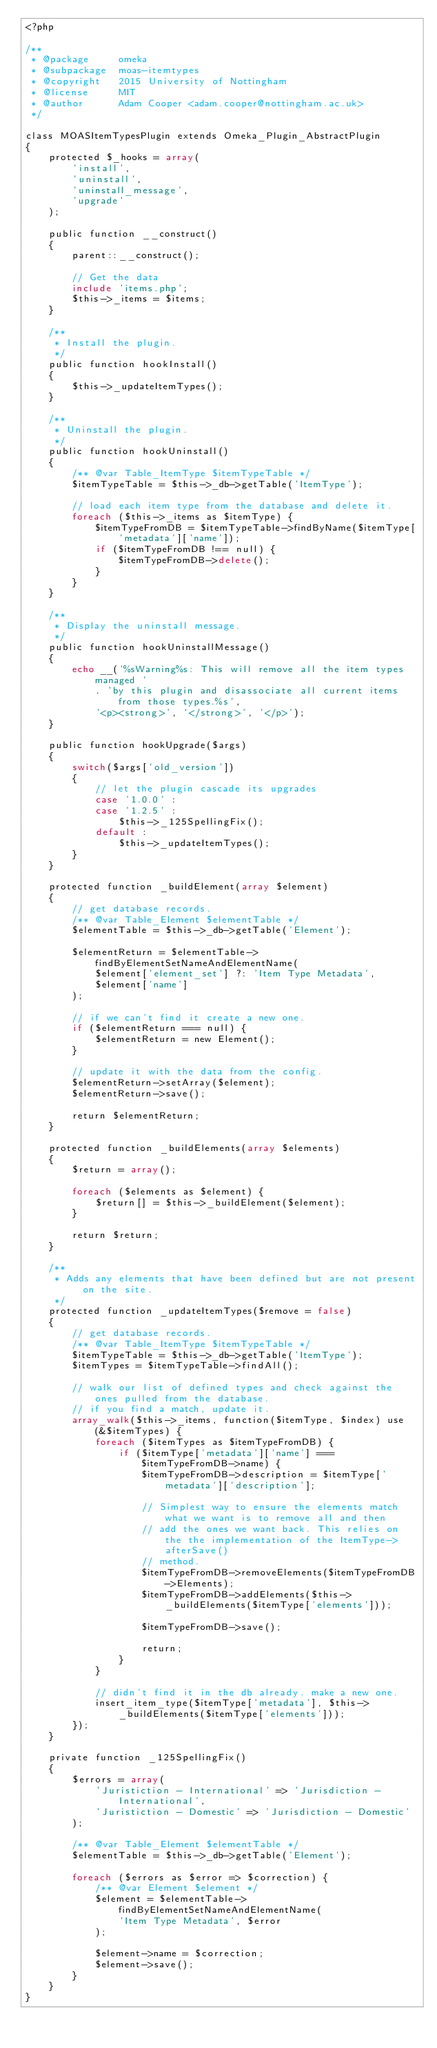Convert code to text. <code><loc_0><loc_0><loc_500><loc_500><_PHP_><?php

/**
 * @package     omeka
 * @subpackage  moas-itemtypes
 * @copyright   2015 University of Nottingham
 * @license     MIT
 * @author      Adam Cooper <adam.cooper@nottingham.ac.uk>
 */

class MOASItemTypesPlugin extends Omeka_Plugin_AbstractPlugin
{
    protected $_hooks = array(
        'install',
        'uninstall',
        'uninstall_message',
        'upgrade'
    );

    public function __construct()
    {
        parent::__construct();

        // Get the data
        include 'items.php';
        $this->_items = $items;
    }

    /**
     * Install the plugin.
     */
    public function hookInstall()
    {
        $this->_updateItemTypes();
    }

    /**
     * Uninstall the plugin.
     */
    public function hookUninstall()
    {
        /** @var Table_ItemType $itemTypeTable */
        $itemTypeTable = $this->_db->getTable('ItemType');

        // load each item type from the database and delete it.
        foreach ($this->_items as $itemType) {
            $itemTypeFromDB = $itemTypeTable->findByName($itemType['metadata']['name']);
            if ($itemTypeFromDB !== null) {
                $itemTypeFromDB->delete();
            }
        }
    }

    /**
     * Display the uninstall message.
     */
    public function hookUninstallMessage()
    {
        echo __('%sWarning%s: This will remove all the item types managed '
            . 'by this plugin and disassociate all current items from those types.%s',
            '<p><strong>', '</strong>', '</p>');
    }

    public function hookUpgrade($args)
    {
        switch($args['old_version'])
        {
            // let the plugin cascade its upgrades
            case '1.0.0' :
            case '1.2.5' :
                $this->_125SpellingFix();
            default :
                $this->_updateItemTypes();
        }
    }

    protected function _buildElement(array $element)
    {
        // get database records.
        /** @var Table_Element $elementTable */
        $elementTable = $this->_db->getTable('Element');

        $elementReturn = $elementTable->findByElementSetNameAndElementName(
            $element['element_set'] ?: 'Item Type Metadata',
            $element['name']
        );

        // if we can't find it create a new one.
        if ($elementReturn === null) {
            $elementReturn = new Element();
        }

        // update it with the data from the config.
        $elementReturn->setArray($element);
        $elementReturn->save();

        return $elementReturn;
    }

    protected function _buildElements(array $elements)
    {
        $return = array();

        foreach ($elements as $element) {
            $return[] = $this->_buildElement($element);
        }

        return $return;
    }

    /**
     * Adds any elements that have been defined but are not present on the site.
     */
    protected function _updateItemTypes($remove = false)
    {
        // get database records.
        /** @var Table_ItemType $itemTypeTable */
        $itemTypeTable = $this->_db->getTable('ItemType');
        $itemTypes = $itemTypeTable->findAll();

        // walk our list of defined types and check against the ones pulled from the database.
        // if you find a match, update it.
        array_walk($this->_items, function($itemType, $index) use (&$itemTypes) {
            foreach ($itemTypes as $itemTypeFromDB) {
                if ($itemType['metadata']['name'] === $itemTypeFromDB->name) {
                    $itemTypeFromDB->description = $itemType['metadata']['description'];

                    // Simplest way to ensure the elements match what we want is to remove all and then
                    // add the ones we want back. This relies on the the implementation of the ItemType->afterSave()
                    // method.
                    $itemTypeFromDB->removeElements($itemTypeFromDB->Elements);
                    $itemTypeFromDB->addElements($this->_buildElements($itemType['elements']));

                    $itemTypeFromDB->save();

                    return;
                }
            }

            // didn't find it in the db already. make a new one.
            insert_item_type($itemType['metadata'], $this->_buildElements($itemType['elements']));
        });
    }

    private function _125SpellingFix()
    {
        $errors = array(
            'Juristiction - International' => 'Jurisdiction - International',
            'Juristiction - Domestic' => 'Jurisdiction - Domestic'
        );

        /** @var Table_Element $elementTable */
        $elementTable = $this->_db->getTable('Element');

        foreach ($errors as $error => $correction) {
            /** @var Element $element */
            $element = $elementTable->findByElementSetNameAndElementName(
                'Item Type Metadata', $error
            );

            $element->name = $correction;
            $element->save();
        }
    }
}
</code> 